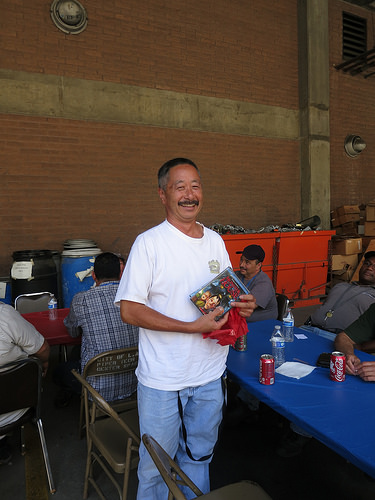<image>
Is there a man on the chair? No. The man is not positioned on the chair. They may be near each other, but the man is not supported by or resting on top of the chair. Is the hat on the man? No. The hat is not positioned on the man. They may be near each other, but the hat is not supported by or resting on top of the man. Is the man next to the ventilator? No. The man is not positioned next to the ventilator. They are located in different areas of the scene. 